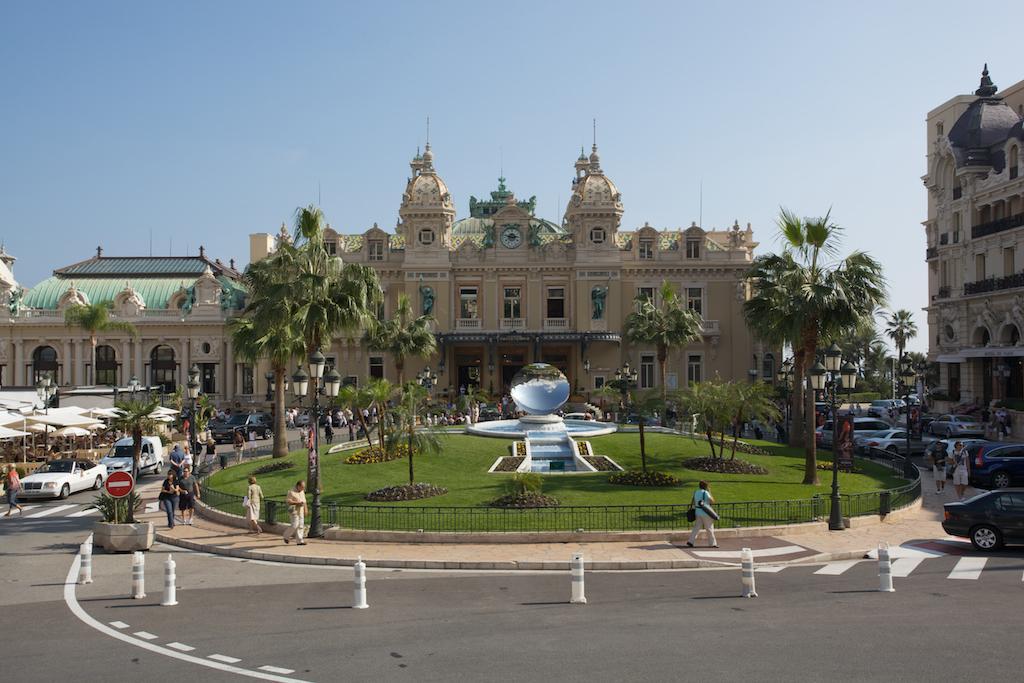Please provide a concise description of this image. This is an outside view. At the bottom there is a road. On the right and left side of the image there are many vehicles on the road and few people are walking on the footpath. In the middle of the image there is a fountain, around this I can see the grass and few trees. In the background there are few buildings. At the top of the image I can see the sky. 